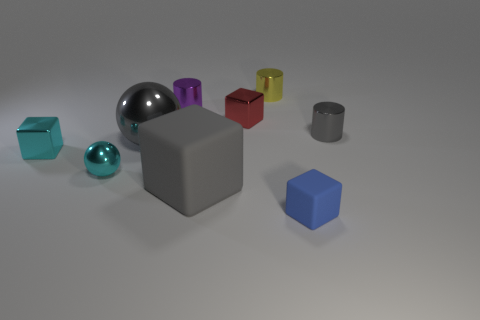Is the large block the same color as the big metal ball?
Keep it short and to the point. Yes. What is the size of the shiny block behind the small metallic cylinder that is on the right side of the small rubber object?
Keep it short and to the point. Small. What number of big rubber things are the same color as the large metal object?
Offer a terse response. 1. There is a gray metallic object that is to the left of the gray object that is to the right of the small yellow shiny cylinder; what shape is it?
Your answer should be compact. Sphere. How many other gray cylinders have the same material as the tiny gray cylinder?
Ensure brevity in your answer.  0. There is a cylinder that is in front of the tiny red metal object; what material is it?
Your response must be concise. Metal. What shape is the matte thing to the right of the shiny block that is behind the tiny cylinder that is in front of the tiny purple metallic cylinder?
Your answer should be compact. Cube. Does the large object that is to the right of the big gray shiny sphere have the same color as the small metal cylinder on the left side of the red block?
Provide a succinct answer. No. Are there fewer cyan metal spheres that are behind the small shiny ball than blue things to the left of the gray metallic cylinder?
Offer a very short reply. Yes. Is there any other thing that is the same shape as the purple shiny object?
Offer a terse response. Yes. 